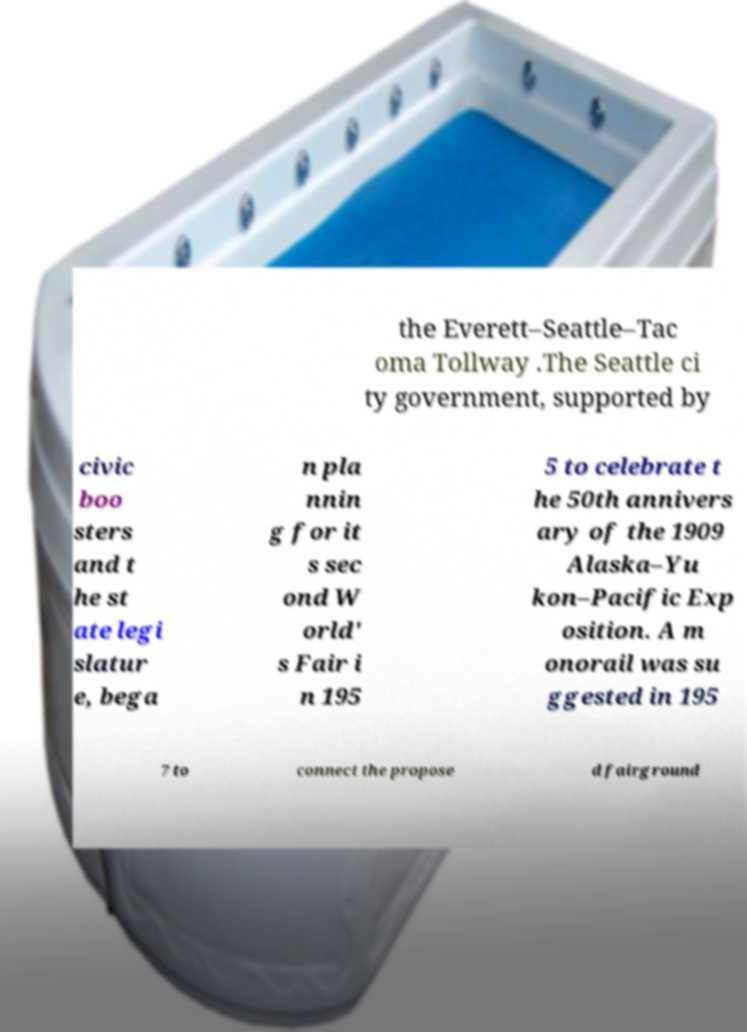For documentation purposes, I need the text within this image transcribed. Could you provide that? the Everett–Seattle–Tac oma Tollway .The Seattle ci ty government, supported by civic boo sters and t he st ate legi slatur e, bega n pla nnin g for it s sec ond W orld' s Fair i n 195 5 to celebrate t he 50th annivers ary of the 1909 Alaska–Yu kon–Pacific Exp osition. A m onorail was su ggested in 195 7 to connect the propose d fairground 